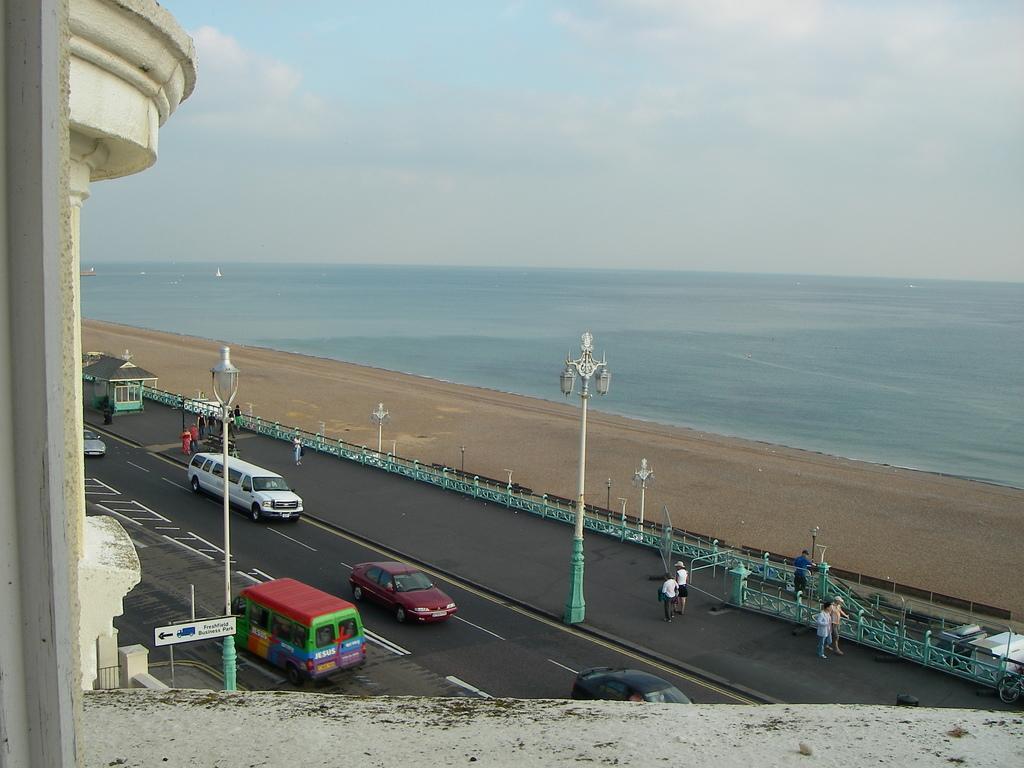Please provide a concise description of this image. In this image we can see vehicles on road, sand, lights, persons, water, sky and clouds. 